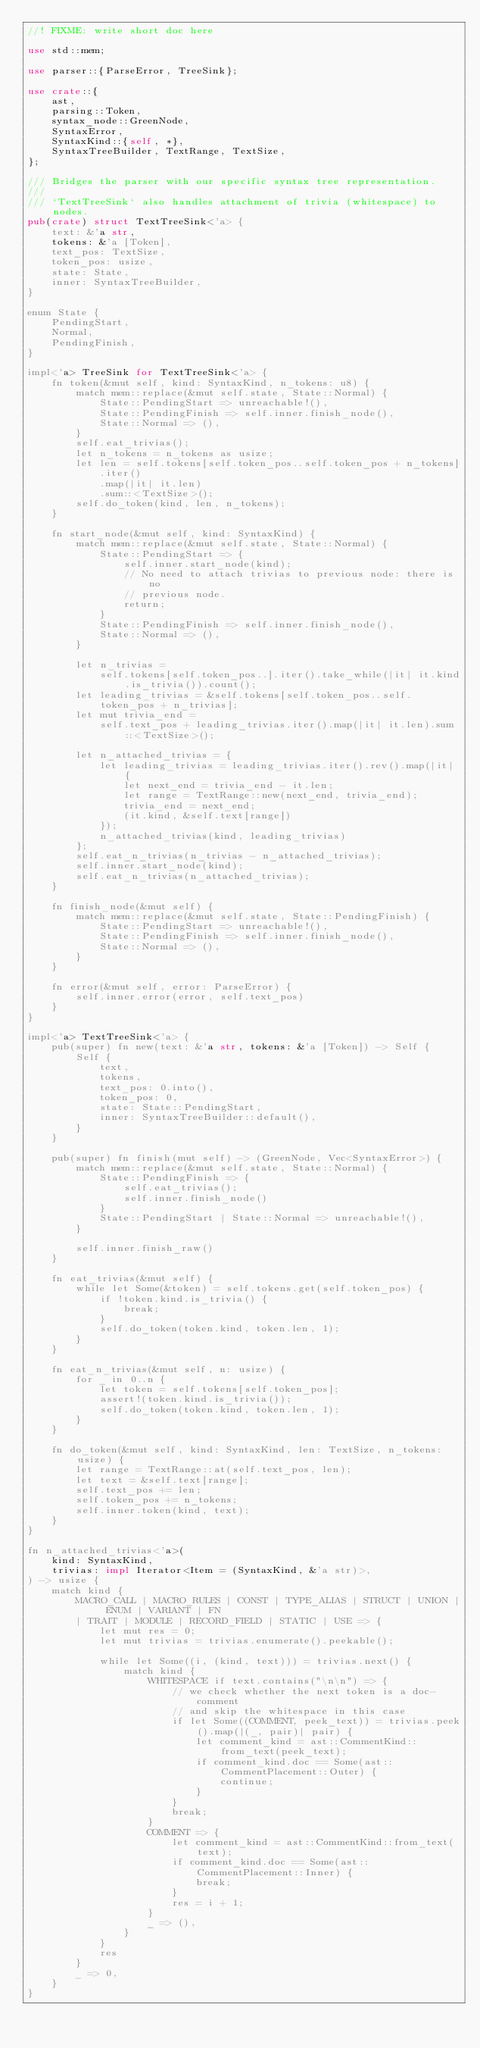Convert code to text. <code><loc_0><loc_0><loc_500><loc_500><_Rust_>//! FIXME: write short doc here

use std::mem;

use parser::{ParseError, TreeSink};

use crate::{
    ast,
    parsing::Token,
    syntax_node::GreenNode,
    SyntaxError,
    SyntaxKind::{self, *},
    SyntaxTreeBuilder, TextRange, TextSize,
};

/// Bridges the parser with our specific syntax tree representation.
///
/// `TextTreeSink` also handles attachment of trivia (whitespace) to nodes.
pub(crate) struct TextTreeSink<'a> {
    text: &'a str,
    tokens: &'a [Token],
    text_pos: TextSize,
    token_pos: usize,
    state: State,
    inner: SyntaxTreeBuilder,
}

enum State {
    PendingStart,
    Normal,
    PendingFinish,
}

impl<'a> TreeSink for TextTreeSink<'a> {
    fn token(&mut self, kind: SyntaxKind, n_tokens: u8) {
        match mem::replace(&mut self.state, State::Normal) {
            State::PendingStart => unreachable!(),
            State::PendingFinish => self.inner.finish_node(),
            State::Normal => (),
        }
        self.eat_trivias();
        let n_tokens = n_tokens as usize;
        let len = self.tokens[self.token_pos..self.token_pos + n_tokens]
            .iter()
            .map(|it| it.len)
            .sum::<TextSize>();
        self.do_token(kind, len, n_tokens);
    }

    fn start_node(&mut self, kind: SyntaxKind) {
        match mem::replace(&mut self.state, State::Normal) {
            State::PendingStart => {
                self.inner.start_node(kind);
                // No need to attach trivias to previous node: there is no
                // previous node.
                return;
            }
            State::PendingFinish => self.inner.finish_node(),
            State::Normal => (),
        }

        let n_trivias =
            self.tokens[self.token_pos..].iter().take_while(|it| it.kind.is_trivia()).count();
        let leading_trivias = &self.tokens[self.token_pos..self.token_pos + n_trivias];
        let mut trivia_end =
            self.text_pos + leading_trivias.iter().map(|it| it.len).sum::<TextSize>();

        let n_attached_trivias = {
            let leading_trivias = leading_trivias.iter().rev().map(|it| {
                let next_end = trivia_end - it.len;
                let range = TextRange::new(next_end, trivia_end);
                trivia_end = next_end;
                (it.kind, &self.text[range])
            });
            n_attached_trivias(kind, leading_trivias)
        };
        self.eat_n_trivias(n_trivias - n_attached_trivias);
        self.inner.start_node(kind);
        self.eat_n_trivias(n_attached_trivias);
    }

    fn finish_node(&mut self) {
        match mem::replace(&mut self.state, State::PendingFinish) {
            State::PendingStart => unreachable!(),
            State::PendingFinish => self.inner.finish_node(),
            State::Normal => (),
        }
    }

    fn error(&mut self, error: ParseError) {
        self.inner.error(error, self.text_pos)
    }
}

impl<'a> TextTreeSink<'a> {
    pub(super) fn new(text: &'a str, tokens: &'a [Token]) -> Self {
        Self {
            text,
            tokens,
            text_pos: 0.into(),
            token_pos: 0,
            state: State::PendingStart,
            inner: SyntaxTreeBuilder::default(),
        }
    }

    pub(super) fn finish(mut self) -> (GreenNode, Vec<SyntaxError>) {
        match mem::replace(&mut self.state, State::Normal) {
            State::PendingFinish => {
                self.eat_trivias();
                self.inner.finish_node()
            }
            State::PendingStart | State::Normal => unreachable!(),
        }

        self.inner.finish_raw()
    }

    fn eat_trivias(&mut self) {
        while let Some(&token) = self.tokens.get(self.token_pos) {
            if !token.kind.is_trivia() {
                break;
            }
            self.do_token(token.kind, token.len, 1);
        }
    }

    fn eat_n_trivias(&mut self, n: usize) {
        for _ in 0..n {
            let token = self.tokens[self.token_pos];
            assert!(token.kind.is_trivia());
            self.do_token(token.kind, token.len, 1);
        }
    }

    fn do_token(&mut self, kind: SyntaxKind, len: TextSize, n_tokens: usize) {
        let range = TextRange::at(self.text_pos, len);
        let text = &self.text[range];
        self.text_pos += len;
        self.token_pos += n_tokens;
        self.inner.token(kind, text);
    }
}

fn n_attached_trivias<'a>(
    kind: SyntaxKind,
    trivias: impl Iterator<Item = (SyntaxKind, &'a str)>,
) -> usize {
    match kind {
        MACRO_CALL | MACRO_RULES | CONST | TYPE_ALIAS | STRUCT | UNION | ENUM | VARIANT | FN
        | TRAIT | MODULE | RECORD_FIELD | STATIC | USE => {
            let mut res = 0;
            let mut trivias = trivias.enumerate().peekable();

            while let Some((i, (kind, text))) = trivias.next() {
                match kind {
                    WHITESPACE if text.contains("\n\n") => {
                        // we check whether the next token is a doc-comment
                        // and skip the whitespace in this case
                        if let Some((COMMENT, peek_text)) = trivias.peek().map(|(_, pair)| pair) {
                            let comment_kind = ast::CommentKind::from_text(peek_text);
                            if comment_kind.doc == Some(ast::CommentPlacement::Outer) {
                                continue;
                            }
                        }
                        break;
                    }
                    COMMENT => {
                        let comment_kind = ast::CommentKind::from_text(text);
                        if comment_kind.doc == Some(ast::CommentPlacement::Inner) {
                            break;
                        }
                        res = i + 1;
                    }
                    _ => (),
                }
            }
            res
        }
        _ => 0,
    }
}
</code> 